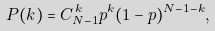Convert formula to latex. <formula><loc_0><loc_0><loc_500><loc_500>P ( k ) = C _ { N - 1 } ^ { \, k } p ^ { k } ( 1 - p ) ^ { N - 1 - k } ,</formula> 